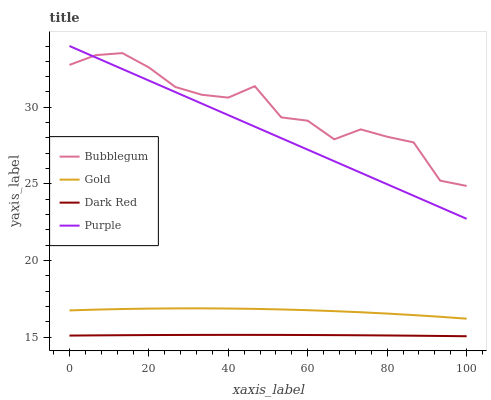Does Dark Red have the minimum area under the curve?
Answer yes or no. Yes. Does Bubblegum have the maximum area under the curve?
Answer yes or no. Yes. Does Gold have the minimum area under the curve?
Answer yes or no. No. Does Gold have the maximum area under the curve?
Answer yes or no. No. Is Purple the smoothest?
Answer yes or no. Yes. Is Bubblegum the roughest?
Answer yes or no. Yes. Is Dark Red the smoothest?
Answer yes or no. No. Is Dark Red the roughest?
Answer yes or no. No. Does Dark Red have the lowest value?
Answer yes or no. Yes. Does Gold have the lowest value?
Answer yes or no. No. Does Purple have the highest value?
Answer yes or no. Yes. Does Gold have the highest value?
Answer yes or no. No. Is Gold less than Bubblegum?
Answer yes or no. Yes. Is Bubblegum greater than Dark Red?
Answer yes or no. Yes. Does Purple intersect Bubblegum?
Answer yes or no. Yes. Is Purple less than Bubblegum?
Answer yes or no. No. Is Purple greater than Bubblegum?
Answer yes or no. No. Does Gold intersect Bubblegum?
Answer yes or no. No. 